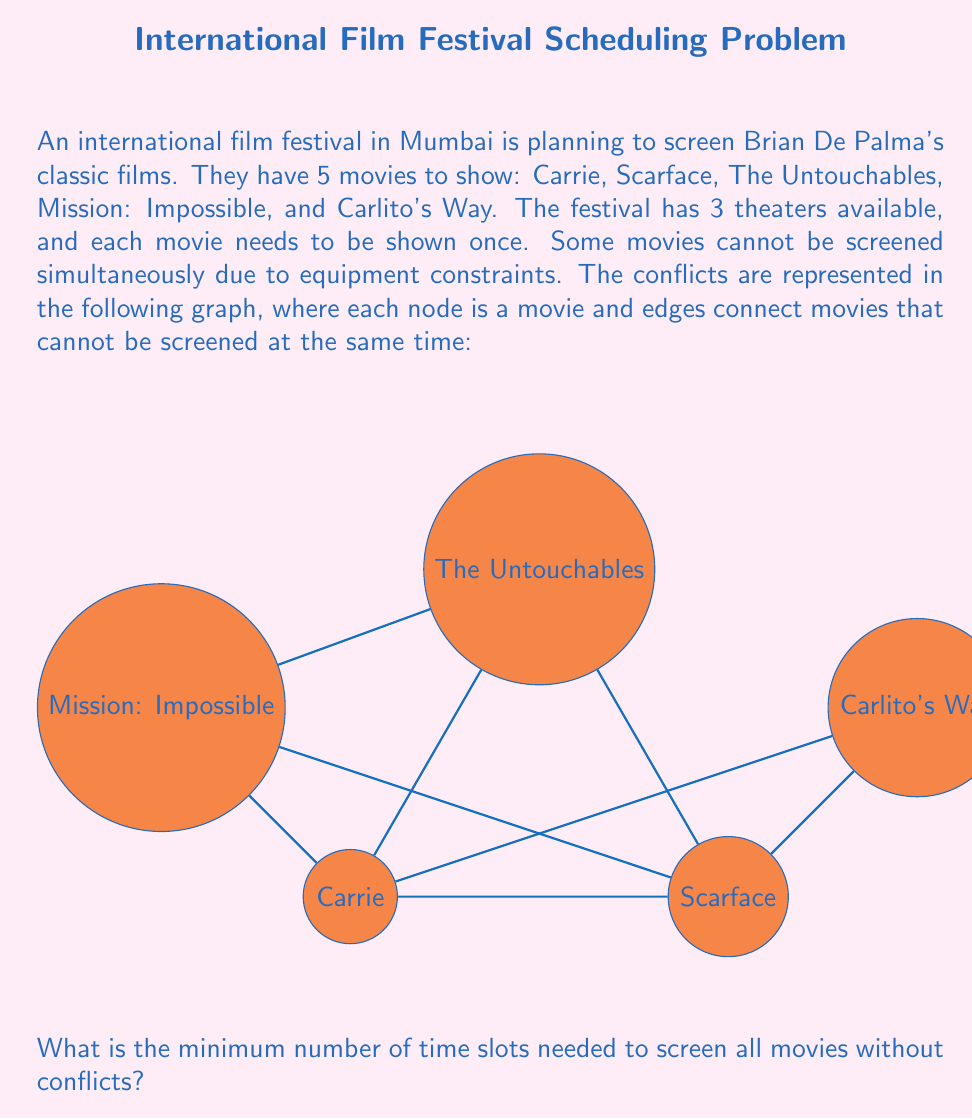Help me with this question. To solve this graph coloring problem, we need to find the chromatic number of the given graph. The chromatic number is the minimum number of colors needed to color the vertices of the graph such that no two adjacent vertices have the same color. In this case, each color represents a time slot.

Let's approach this step-by-step:

1) First, we observe that the graph has a triangle formed by Carrie, Scarface, and The Untouchables. This means we need at least 3 colors (time slots).

2) Let's try to color the graph with 3 colors:
   - Assign color 1 to Carrie
   - Assign color 2 to Scarface
   - Assign color 3 to The Untouchables

3) Now, we need to color Mission: Impossible:
   - It can't be color 1 (conflicts with Carrie)
   - It can't be color 2 (conflicts with Scarface)
   - It can be color 3, as it doesn't conflict with The Untouchables

4) Finally, we need to color Carlito's Way:
   - It can't be color 1 (conflicts with Carrie)
   - It can't be color 2 (conflicts with Scarface)
   - It can be color 3, as it doesn't conflict with The Untouchables or Mission: Impossible

5) We have successfully colored the graph with 3 colors, which means we can schedule all movies in 3 time slots without conflicts.

The coloring can be represented as:
- Time Slot 1: Carrie
- Time Slot 2: Scarface
- Time Slot 3: The Untouchables, Mission: Impossible, Carlito's Way

This coloring is optimal because we know we need at least 3 colors due to the triangle in the graph, and we've shown that 3 colors are sufficient.
Answer: 3 